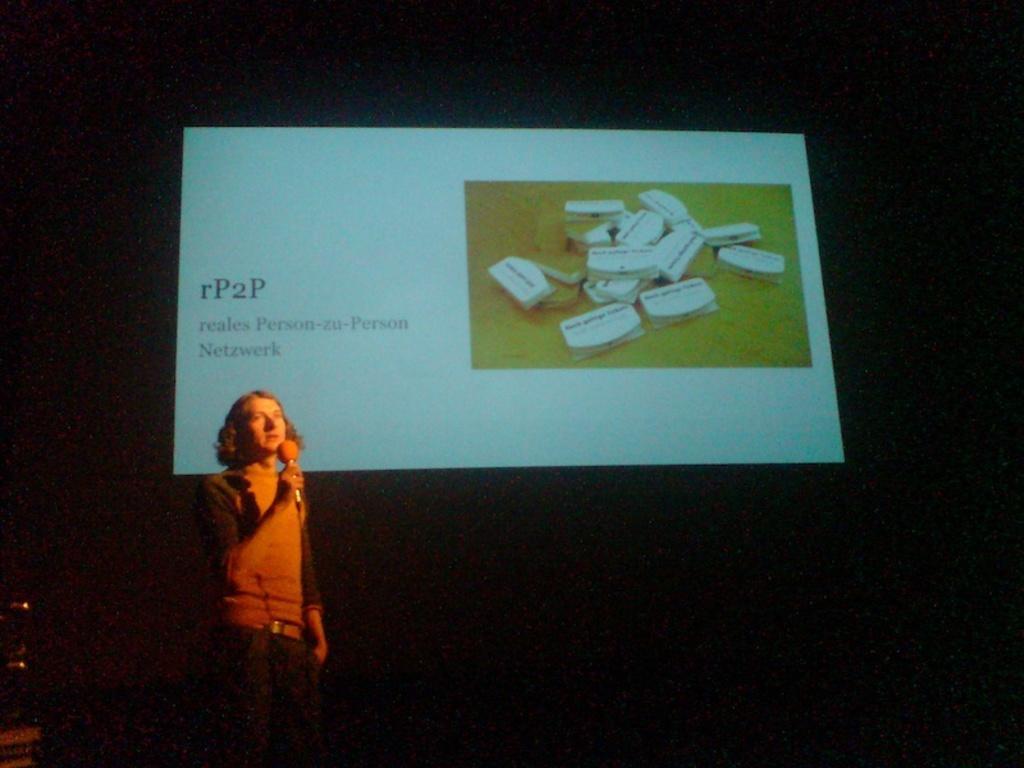Can you describe this image briefly? In this image we can see a person holding a microphone in his hand. In the background, we can see a screen with a group of objects and some text on it. 